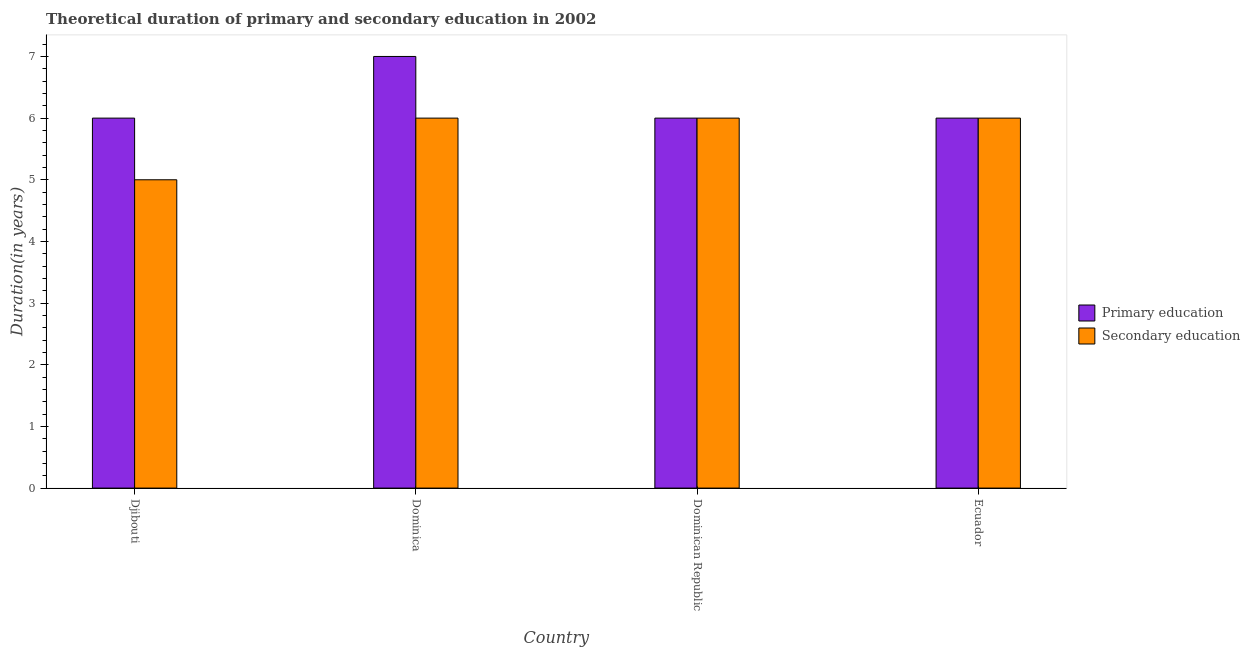Are the number of bars per tick equal to the number of legend labels?
Ensure brevity in your answer.  Yes. How many bars are there on the 4th tick from the left?
Make the answer very short. 2. How many bars are there on the 2nd tick from the right?
Make the answer very short. 2. What is the label of the 1st group of bars from the left?
Provide a succinct answer. Djibouti. What is the duration of secondary education in Dominica?
Provide a short and direct response. 6. Across all countries, what is the minimum duration of primary education?
Ensure brevity in your answer.  6. In which country was the duration of primary education maximum?
Your answer should be very brief. Dominica. In which country was the duration of secondary education minimum?
Provide a succinct answer. Djibouti. What is the total duration of secondary education in the graph?
Provide a succinct answer. 23. What is the difference between the duration of secondary education in Djibouti and that in Ecuador?
Give a very brief answer. -1. What is the difference between the duration of primary education in Ecuador and the duration of secondary education in Djibouti?
Keep it short and to the point. 1. What is the average duration of primary education per country?
Ensure brevity in your answer.  6.25. In how many countries, is the duration of primary education greater than 0.6000000000000001 years?
Ensure brevity in your answer.  4. What is the ratio of the duration of secondary education in Djibouti to that in Dominican Republic?
Your answer should be very brief. 0.83. Is the difference between the duration of secondary education in Djibouti and Ecuador greater than the difference between the duration of primary education in Djibouti and Ecuador?
Provide a succinct answer. No. What is the difference between the highest and the second highest duration of secondary education?
Ensure brevity in your answer.  0. What is the difference between the highest and the lowest duration of secondary education?
Your answer should be compact. 1. What does the 1st bar from the left in Djibouti represents?
Make the answer very short. Primary education. What does the 2nd bar from the right in Dominican Republic represents?
Offer a terse response. Primary education. How many bars are there?
Your response must be concise. 8. Are all the bars in the graph horizontal?
Give a very brief answer. No. Does the graph contain grids?
Provide a succinct answer. No. How many legend labels are there?
Offer a terse response. 2. How are the legend labels stacked?
Provide a succinct answer. Vertical. What is the title of the graph?
Offer a terse response. Theoretical duration of primary and secondary education in 2002. Does "Primary income" appear as one of the legend labels in the graph?
Keep it short and to the point. No. What is the label or title of the Y-axis?
Give a very brief answer. Duration(in years). What is the Duration(in years) of Primary education in Djibouti?
Ensure brevity in your answer.  6. What is the Duration(in years) in Secondary education in Dominica?
Your answer should be compact. 6. Across all countries, what is the maximum Duration(in years) in Secondary education?
Make the answer very short. 6. Across all countries, what is the minimum Duration(in years) in Primary education?
Offer a terse response. 6. What is the difference between the Duration(in years) of Primary education in Dominica and that in Ecuador?
Ensure brevity in your answer.  1. What is the difference between the Duration(in years) in Secondary education in Dominica and that in Ecuador?
Your answer should be compact. 0. What is the difference between the Duration(in years) of Primary education in Dominican Republic and that in Ecuador?
Ensure brevity in your answer.  0. What is the difference between the Duration(in years) in Primary education in Djibouti and the Duration(in years) in Secondary education in Ecuador?
Your answer should be very brief. 0. What is the difference between the Duration(in years) of Primary education in Dominica and the Duration(in years) of Secondary education in Dominican Republic?
Your answer should be compact. 1. What is the difference between the Duration(in years) of Primary education in Dominican Republic and the Duration(in years) of Secondary education in Ecuador?
Give a very brief answer. 0. What is the average Duration(in years) in Primary education per country?
Make the answer very short. 6.25. What is the average Duration(in years) in Secondary education per country?
Provide a short and direct response. 5.75. What is the difference between the Duration(in years) in Primary education and Duration(in years) in Secondary education in Djibouti?
Your answer should be very brief. 1. What is the difference between the Duration(in years) of Primary education and Duration(in years) of Secondary education in Dominica?
Offer a terse response. 1. What is the ratio of the Duration(in years) of Secondary education in Djibouti to that in Dominica?
Make the answer very short. 0.83. What is the ratio of the Duration(in years) of Primary education in Djibouti to that in Dominican Republic?
Keep it short and to the point. 1. What is the ratio of the Duration(in years) in Primary education in Djibouti to that in Ecuador?
Ensure brevity in your answer.  1. What is the ratio of the Duration(in years) of Primary education in Dominica to that in Dominican Republic?
Keep it short and to the point. 1.17. What is the ratio of the Duration(in years) of Secondary education in Dominica to that in Dominican Republic?
Your answer should be very brief. 1. What is the ratio of the Duration(in years) of Primary education in Dominica to that in Ecuador?
Give a very brief answer. 1.17. What is the ratio of the Duration(in years) in Secondary education in Dominica to that in Ecuador?
Keep it short and to the point. 1. What is the ratio of the Duration(in years) of Secondary education in Dominican Republic to that in Ecuador?
Provide a short and direct response. 1. What is the difference between the highest and the second highest Duration(in years) of Primary education?
Offer a very short reply. 1. What is the difference between the highest and the second highest Duration(in years) of Secondary education?
Ensure brevity in your answer.  0. What is the difference between the highest and the lowest Duration(in years) of Primary education?
Ensure brevity in your answer.  1. What is the difference between the highest and the lowest Duration(in years) of Secondary education?
Offer a very short reply. 1. 